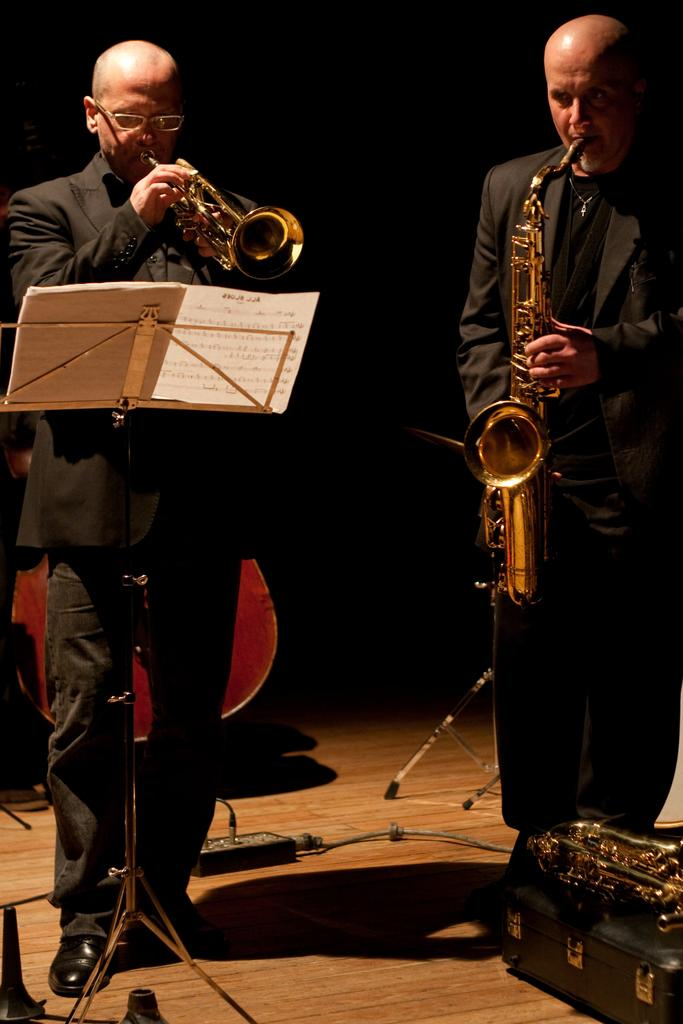What are the people in the image doing? The people in the image are playing musical instruments. What can be seen on the floor in the image? There are objects on the floor in the image. How would you describe the lighting in the image? The background of the image is dark. Can you see the toe of the person playing the guitar in the image? There is no specific person or body part mentioned in the image, so it is not possible to determine if a toe is visible. 